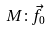<formula> <loc_0><loc_0><loc_500><loc_500>M \colon { \vec { f } } _ { 0 }</formula> 